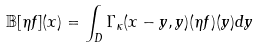<formula> <loc_0><loc_0><loc_500><loc_500>\mathbb { B } [ \eta f ] ( x ) = \int _ { D } \Gamma _ { \kappa } ( x - y , y ) ( \eta f ) ( y ) d y</formula> 